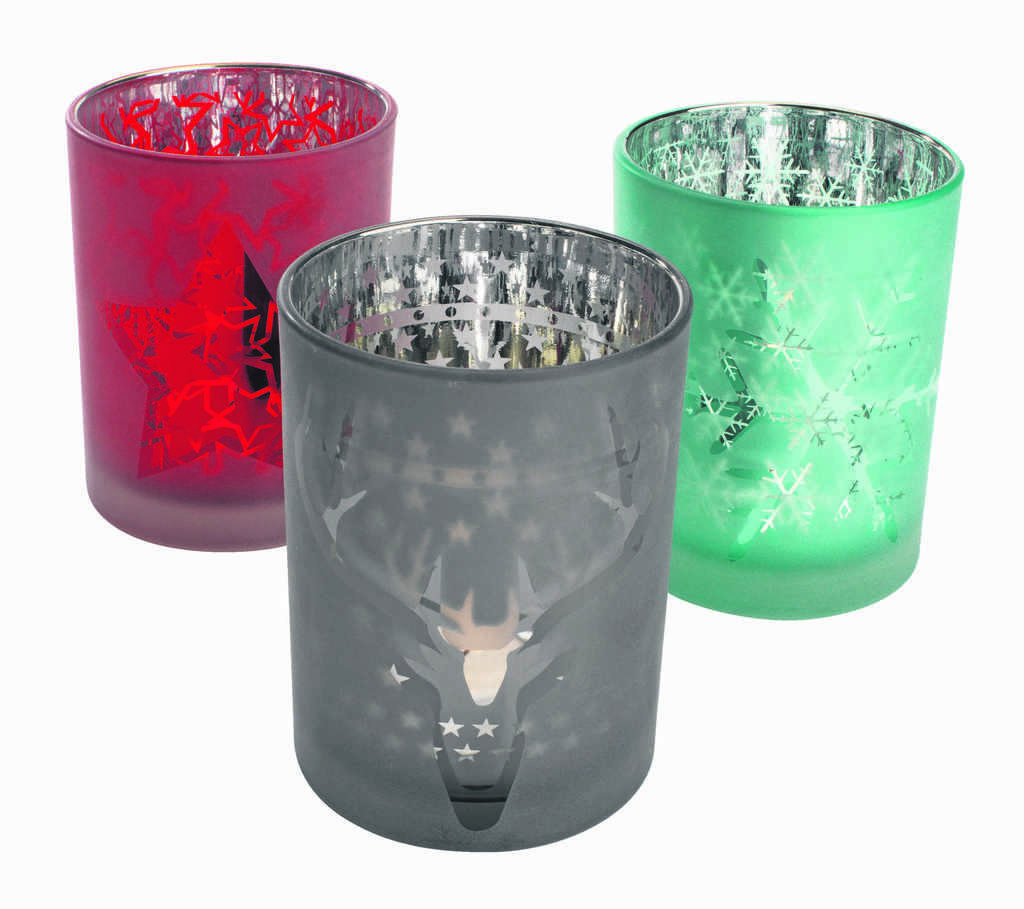What type of objects are present in the image? There are glass objects in the image. Can you describe the appearance of the glass objects? The glass objects have different colors and designs. What type of lettuce can be seen in the image? There is no lettuce present in the image; it features glass objects with different colors and designs. 